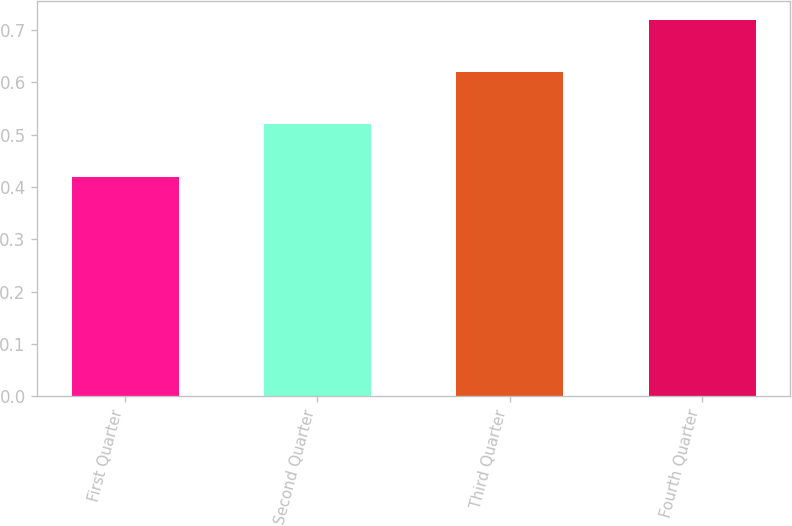Convert chart. <chart><loc_0><loc_0><loc_500><loc_500><bar_chart><fcel>First Quarter<fcel>Second Quarter<fcel>Third Quarter<fcel>Fourth Quarter<nl><fcel>0.42<fcel>0.52<fcel>0.62<fcel>0.72<nl></chart> 